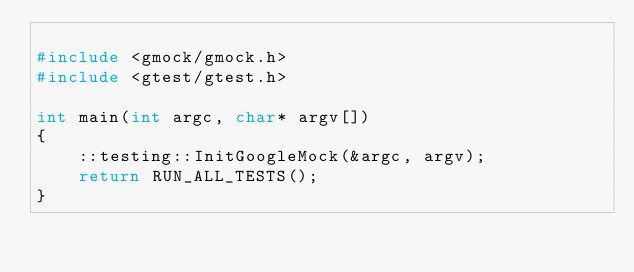<code> <loc_0><loc_0><loc_500><loc_500><_C++_>
#include <gmock/gmock.h>
#include <gtest/gtest.h>

int main(int argc, char* argv[])
{
    ::testing::InitGoogleMock(&argc, argv);
    return RUN_ALL_TESTS();
}
</code> 